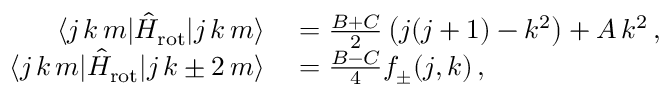Convert formula to latex. <formula><loc_0><loc_0><loc_500><loc_500>\begin{array} { r l } { \langle j \, k \, m | \hat { H } _ { r o t } | j \, k \, m \rangle } & = \frac { B + C } { 2 } \left ( j ( j + 1 ) - k ^ { 2 } \right ) + A \, k ^ { 2 } \, , } \\ { \langle j \, k \, m | \hat { H } _ { r o t } | j \, k \pm 2 \, m \rangle } & = \frac { B - C } { 4 } f _ { \pm } ( j , k ) \, , } \end{array}</formula> 